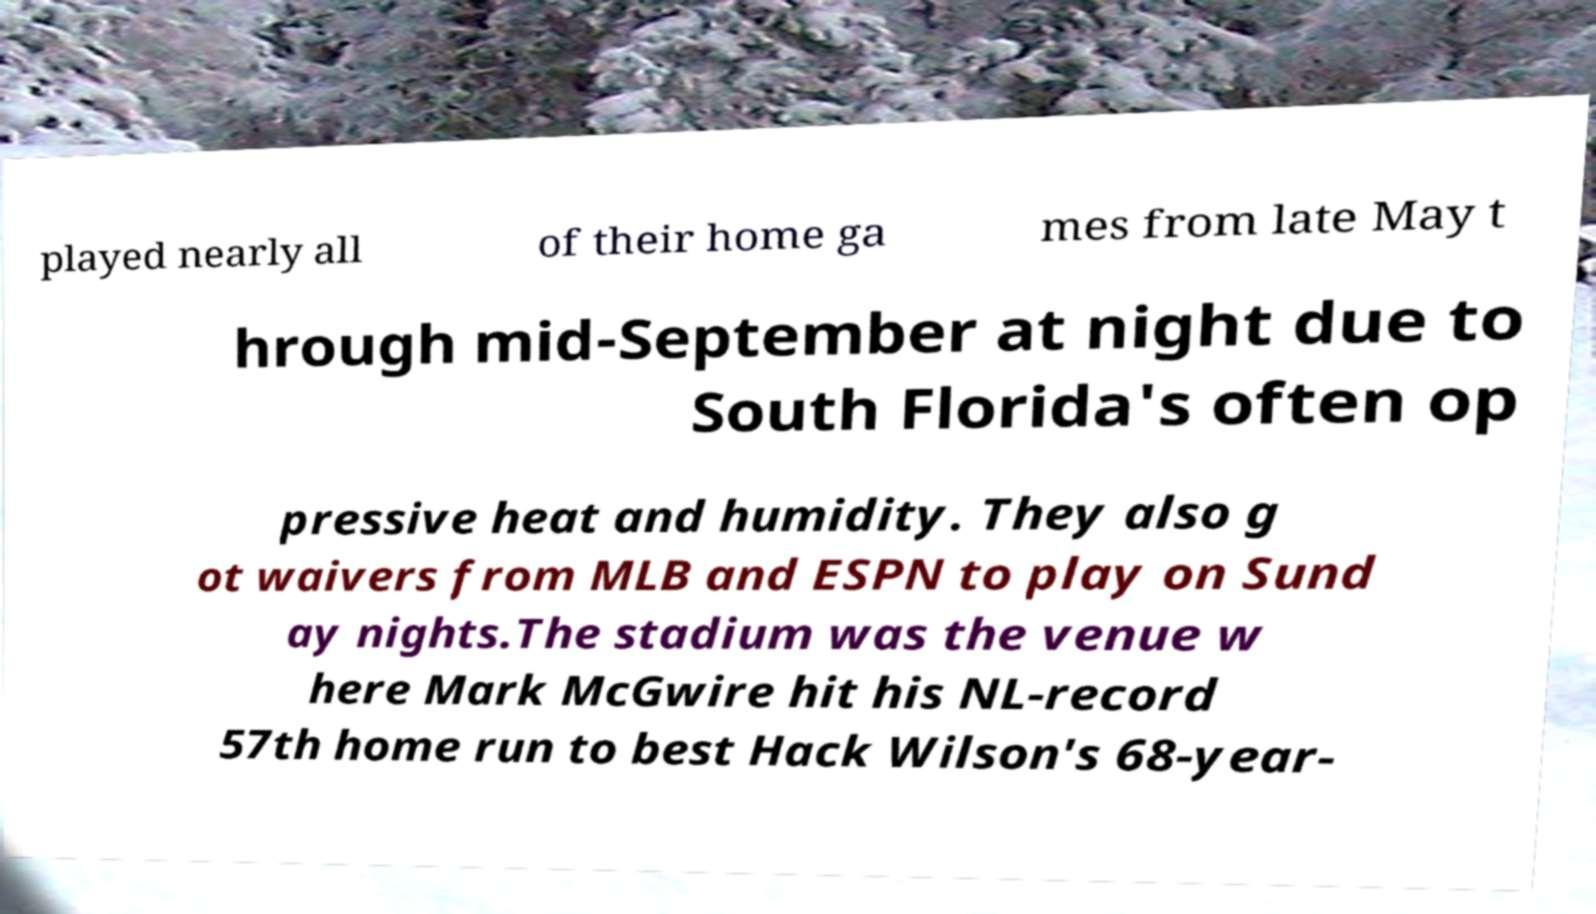Could you assist in decoding the text presented in this image and type it out clearly? played nearly all of their home ga mes from late May t hrough mid-September at night due to South Florida's often op pressive heat and humidity. They also g ot waivers from MLB and ESPN to play on Sund ay nights.The stadium was the venue w here Mark McGwire hit his NL-record 57th home run to best Hack Wilson's 68-year- 